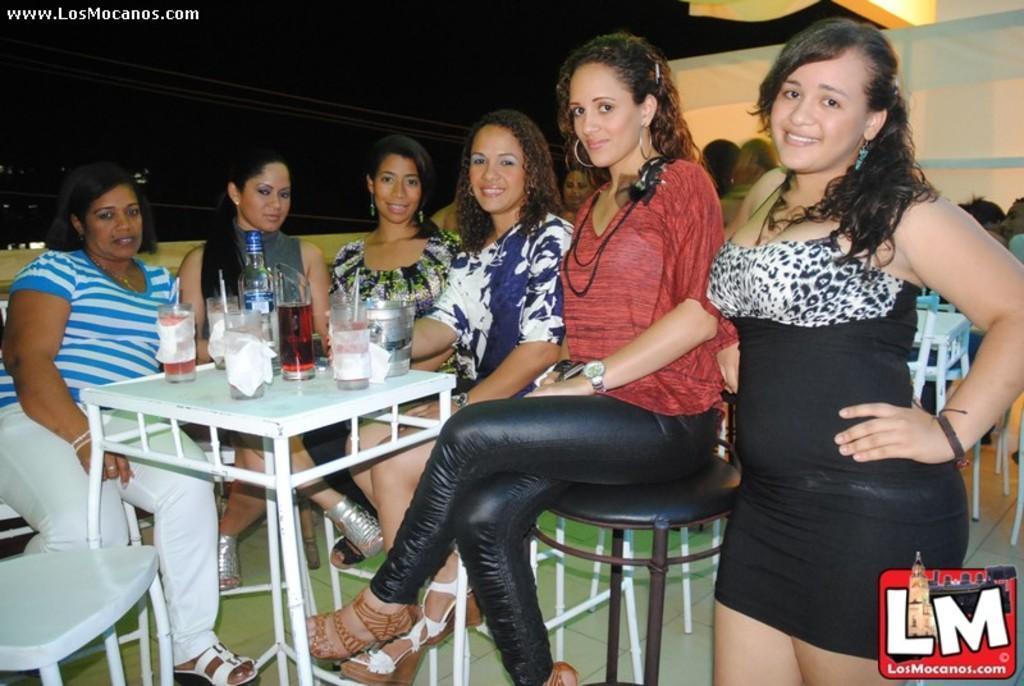Could you give a brief overview of what you see in this image? In this image i can see few women sitting on chairs in front of a table and a woman standing beside them. On the table i can see few glasses and a bottle. In the background i can see few people sitting. 